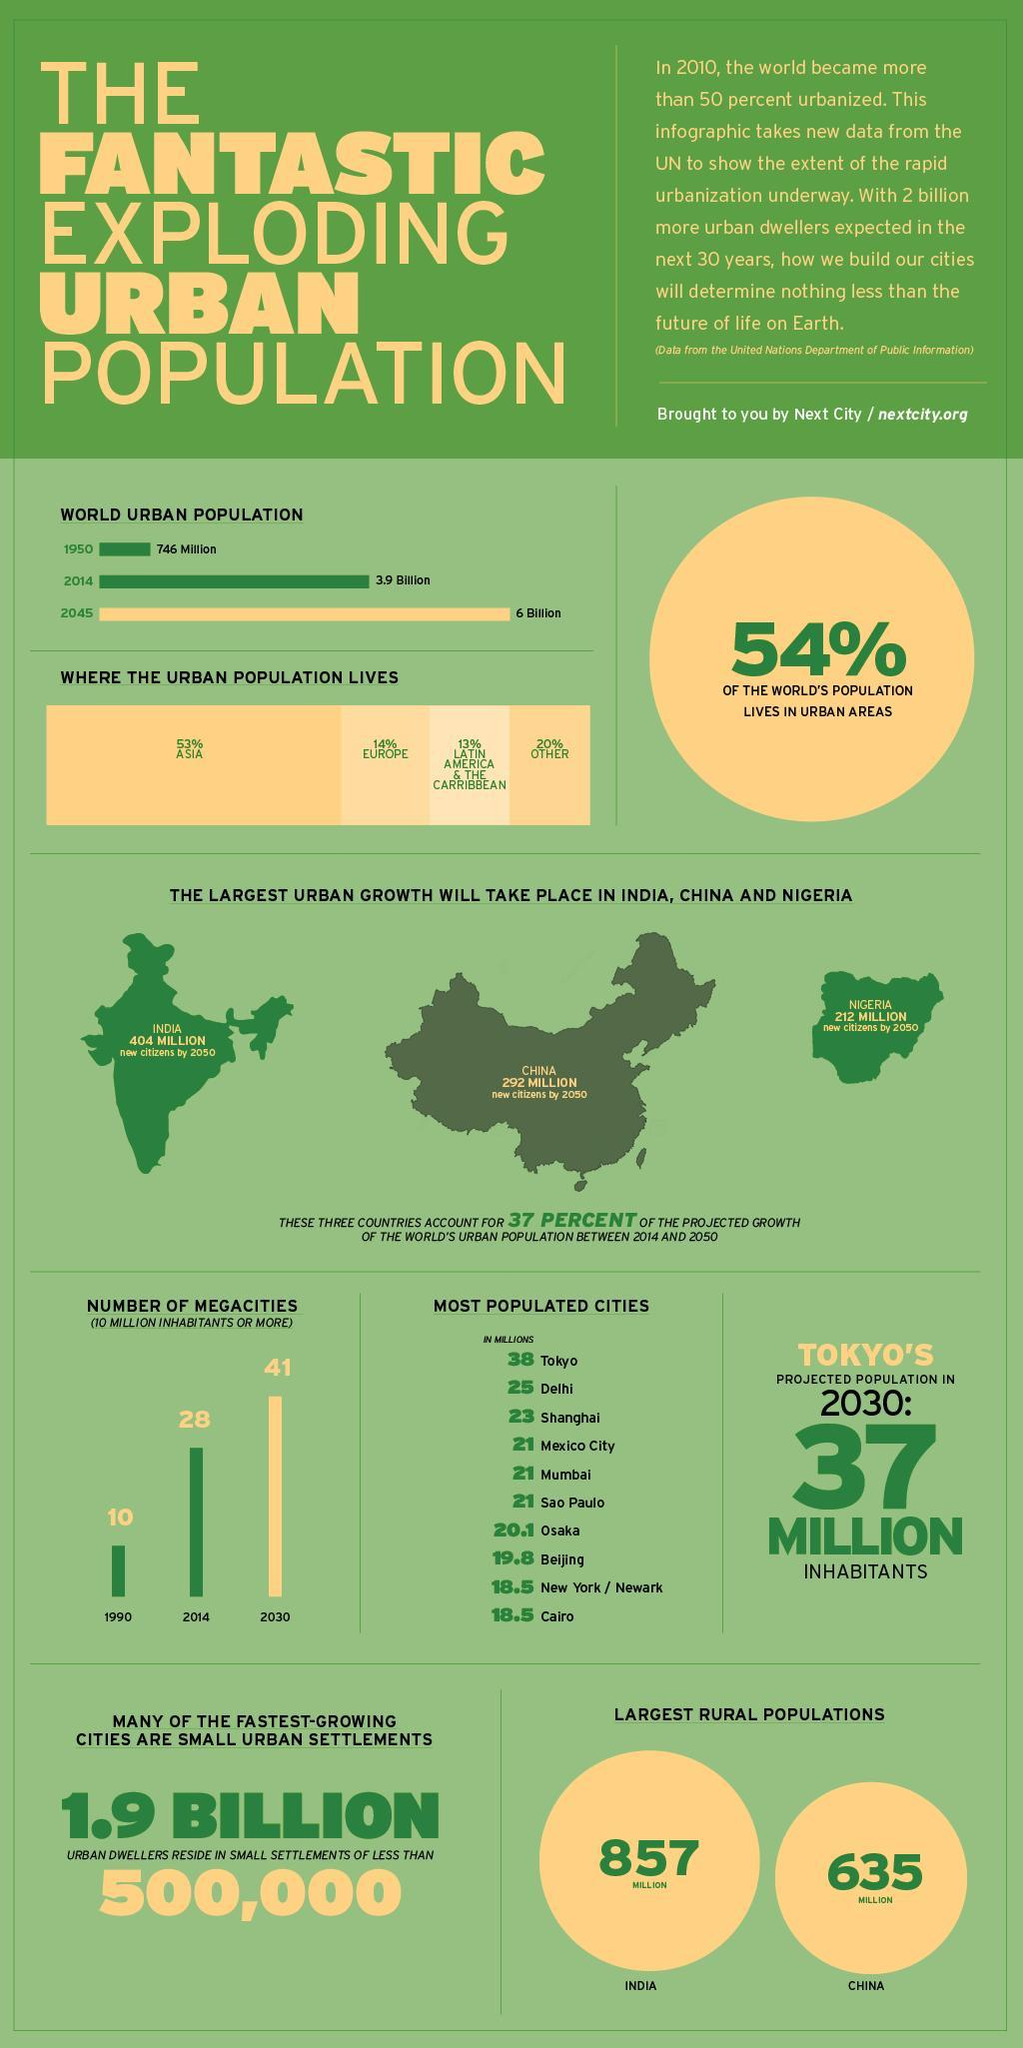What will be the total new citizens in millions by 2050 in India, China and Nigeria togehter
Answer the question with a short phrase. 908 What is the population difference in billion between 2045 and 2014 2.1 What has been the increase in megacities from 1990 to 2014 18 Which cities have population same as Mumbai Mexico City, Sao Paulo What is the total % of urban population in Asia and Europe 67 What is the difference in million in the population between Delhi and Mumbai 4 How much more rural population in millions does India have than China 222 